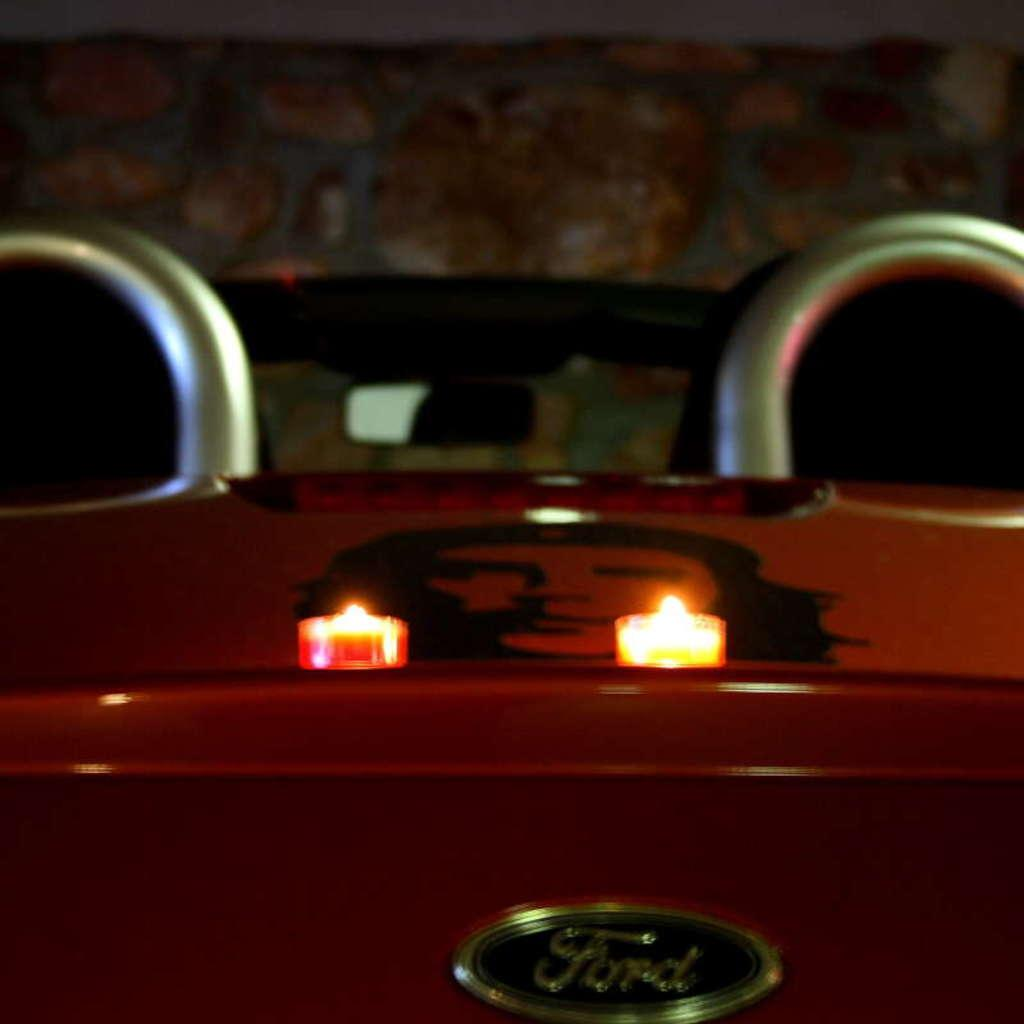How many candles are present in the image? There are 2 candles in the image. Where are the candles located in the image? The candles are in the middle of the image. What else can be seen in the image besides the candles? There is the name of a company in the image. What type of company might the name be associated with? The company name is associated with a vehicle. How many eggs are present in the image? There are no eggs present in the image. What does the company name have to do with peace in the image? The company name does not have anything to do with peace in the image, as there is no mention of peace or any related concepts. 